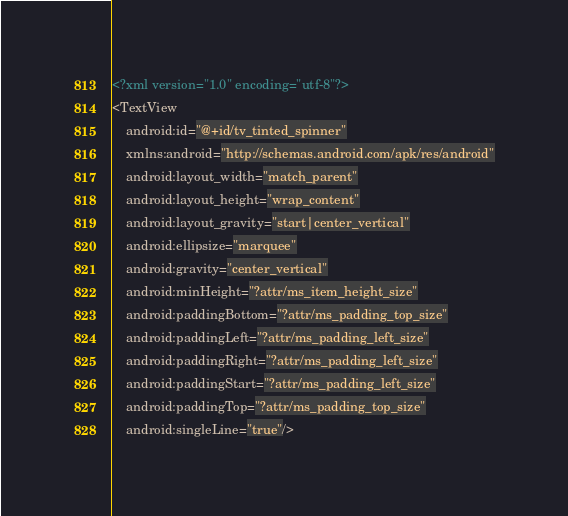Convert code to text. <code><loc_0><loc_0><loc_500><loc_500><_XML_><?xml version="1.0" encoding="utf-8"?>
<TextView
    android:id="@+id/tv_tinted_spinner"
    xmlns:android="http://schemas.android.com/apk/res/android"
    android:layout_width="match_parent"
    android:layout_height="wrap_content"
    android:layout_gravity="start|center_vertical"
    android:ellipsize="marquee"
    android:gravity="center_vertical"
    android:minHeight="?attr/ms_item_height_size"
    android:paddingBottom="?attr/ms_padding_top_size"
    android:paddingLeft="?attr/ms_padding_left_size"
    android:paddingRight="?attr/ms_padding_left_size"
    android:paddingStart="?attr/ms_padding_left_size"
    android:paddingTop="?attr/ms_padding_top_size"
    android:singleLine="true"/>

</code> 